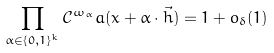Convert formula to latex. <formula><loc_0><loc_0><loc_500><loc_500>\prod _ { \alpha \in \{ 0 , 1 \} ^ { k } } \mathcal { C } ^ { \omega _ { \alpha } } a ( x + \alpha \cdot \vec { h } ) = 1 + o _ { \delta } ( 1 )</formula> 